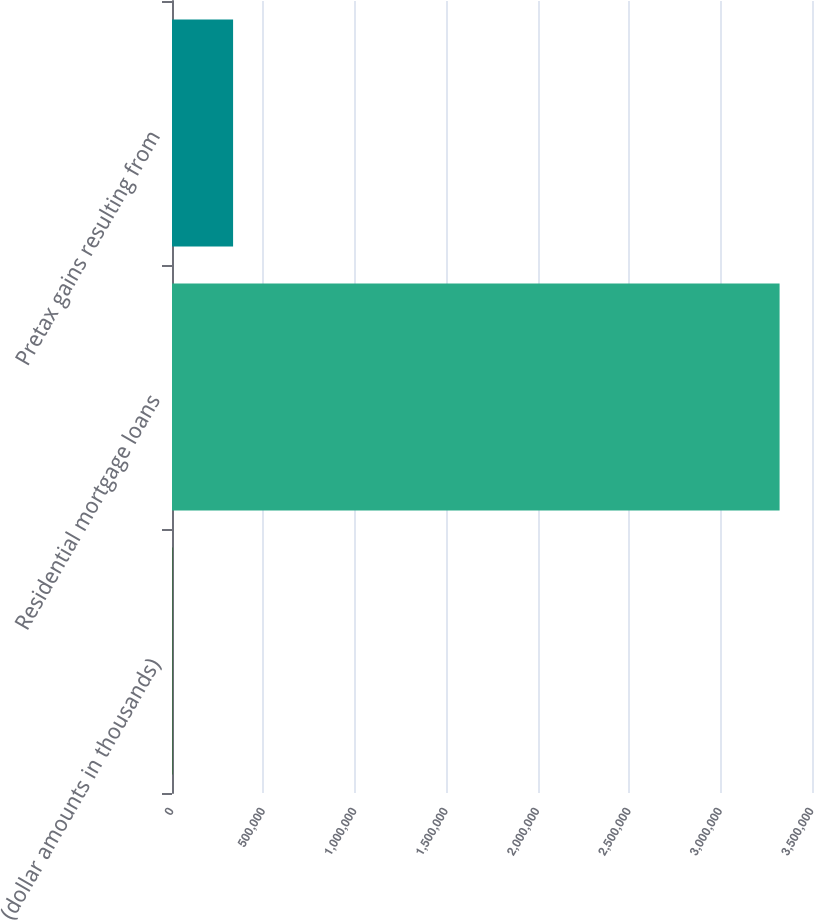Convert chart to OTSL. <chart><loc_0><loc_0><loc_500><loc_500><bar_chart><fcel>(dollar amounts in thousands)<fcel>Residential mortgage loans<fcel>Pretax gains resulting from<nl><fcel>2015<fcel>3.32272e+06<fcel>334086<nl></chart> 